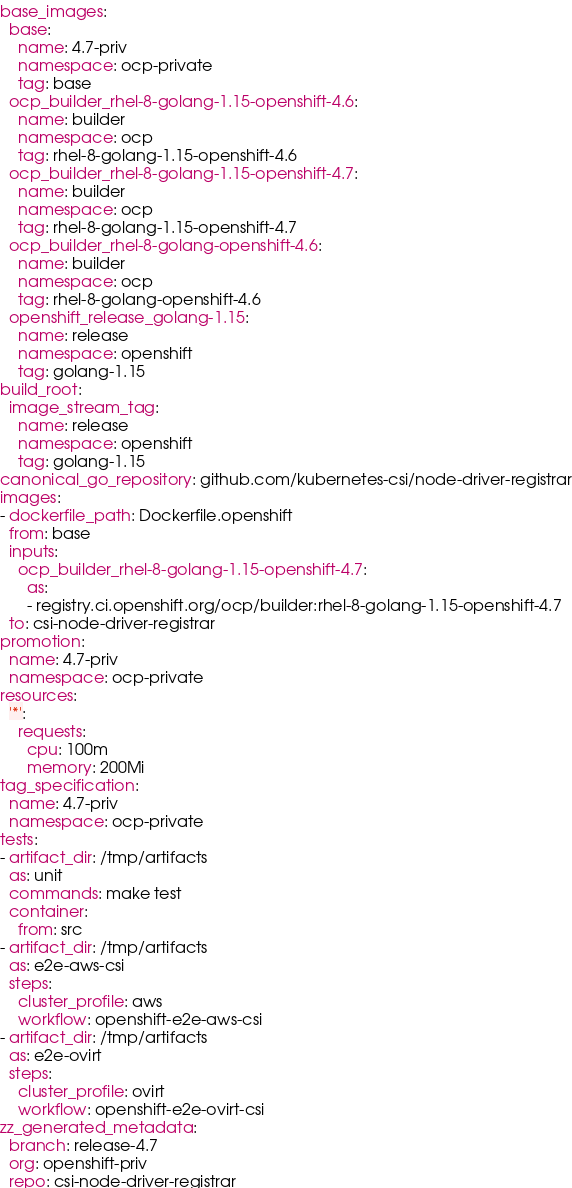Convert code to text. <code><loc_0><loc_0><loc_500><loc_500><_YAML_>base_images:
  base:
    name: 4.7-priv
    namespace: ocp-private
    tag: base
  ocp_builder_rhel-8-golang-1.15-openshift-4.6:
    name: builder
    namespace: ocp
    tag: rhel-8-golang-1.15-openshift-4.6
  ocp_builder_rhel-8-golang-1.15-openshift-4.7:
    name: builder
    namespace: ocp
    tag: rhel-8-golang-1.15-openshift-4.7
  ocp_builder_rhel-8-golang-openshift-4.6:
    name: builder
    namespace: ocp
    tag: rhel-8-golang-openshift-4.6
  openshift_release_golang-1.15:
    name: release
    namespace: openshift
    tag: golang-1.15
build_root:
  image_stream_tag:
    name: release
    namespace: openshift
    tag: golang-1.15
canonical_go_repository: github.com/kubernetes-csi/node-driver-registrar
images:
- dockerfile_path: Dockerfile.openshift
  from: base
  inputs:
    ocp_builder_rhel-8-golang-1.15-openshift-4.7:
      as:
      - registry.ci.openshift.org/ocp/builder:rhel-8-golang-1.15-openshift-4.7
  to: csi-node-driver-registrar
promotion:
  name: 4.7-priv
  namespace: ocp-private
resources:
  '*':
    requests:
      cpu: 100m
      memory: 200Mi
tag_specification:
  name: 4.7-priv
  namespace: ocp-private
tests:
- artifact_dir: /tmp/artifacts
  as: unit
  commands: make test
  container:
    from: src
- artifact_dir: /tmp/artifacts
  as: e2e-aws-csi
  steps:
    cluster_profile: aws
    workflow: openshift-e2e-aws-csi
- artifact_dir: /tmp/artifacts
  as: e2e-ovirt
  steps:
    cluster_profile: ovirt
    workflow: openshift-e2e-ovirt-csi
zz_generated_metadata:
  branch: release-4.7
  org: openshift-priv
  repo: csi-node-driver-registrar
</code> 